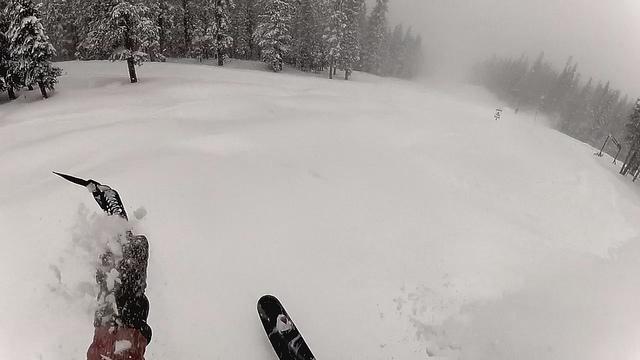Is it winter?
Quick response, please. Yes. Is this a color or black and white photo?
Short answer required. Color. Is this natural beauty?
Write a very short answer. Yes. 